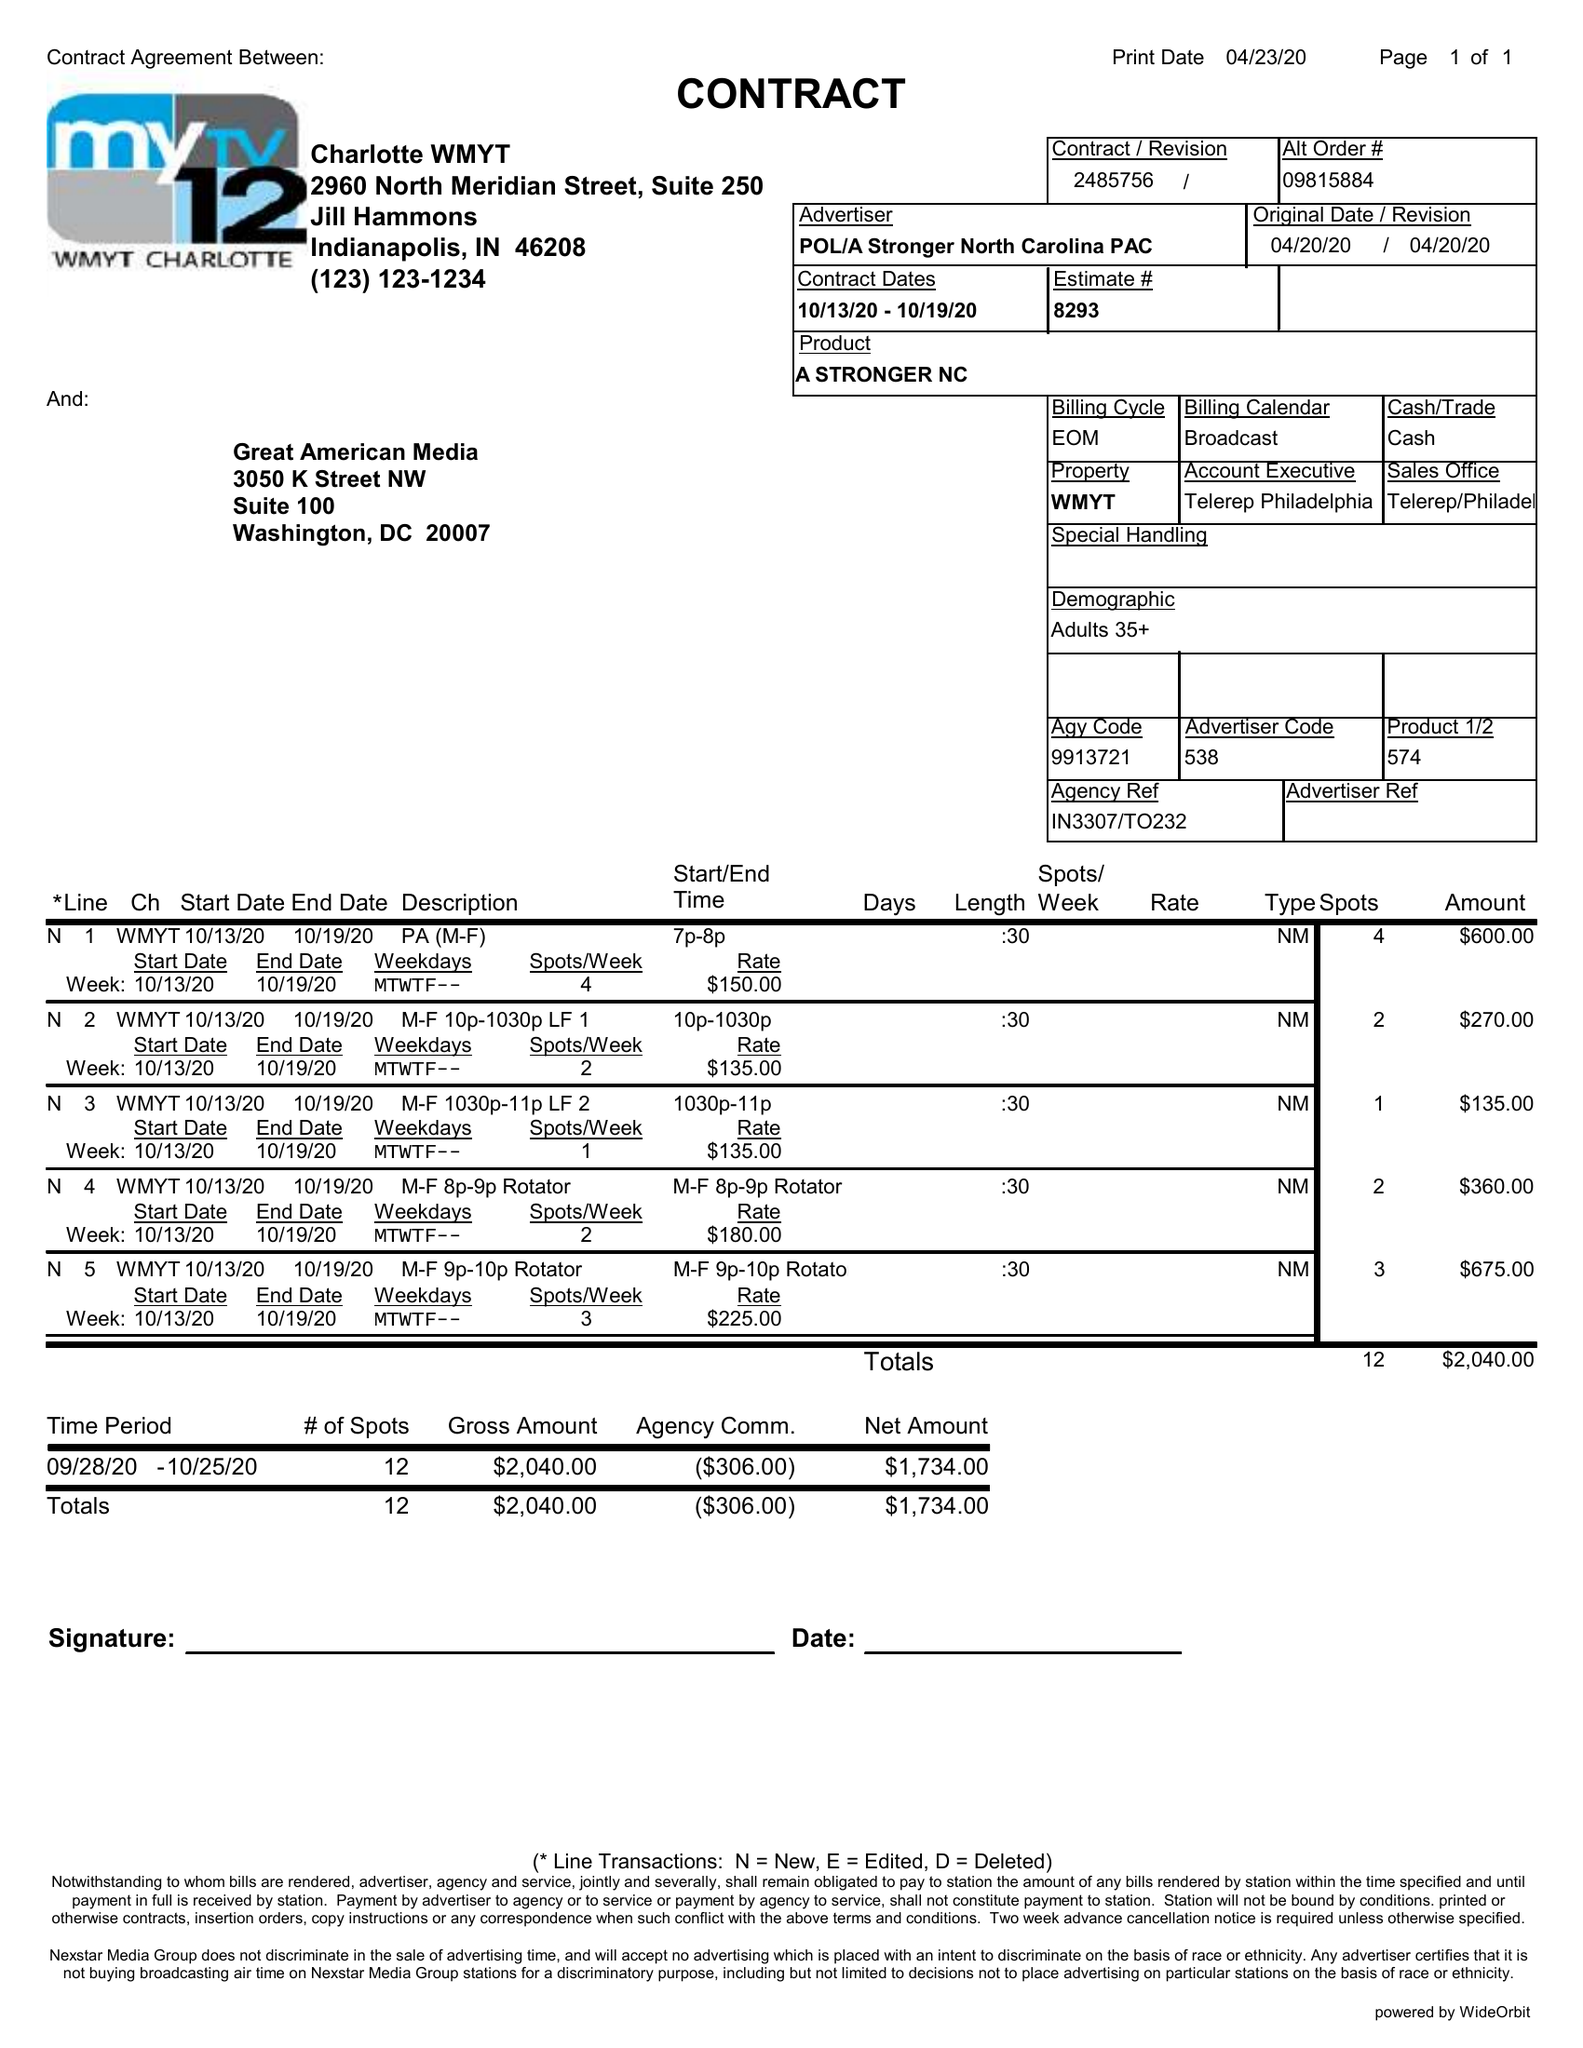What is the value for the gross_amount?
Answer the question using a single word or phrase. 2040.00 